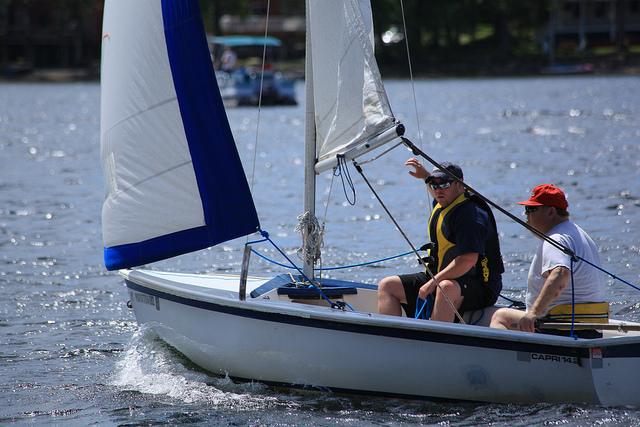What is powering the boat?
Quick response, please. Wind. What color is the water?
Be succinct. Blue. How many people are in the boat?
Give a very brief answer. 2. 